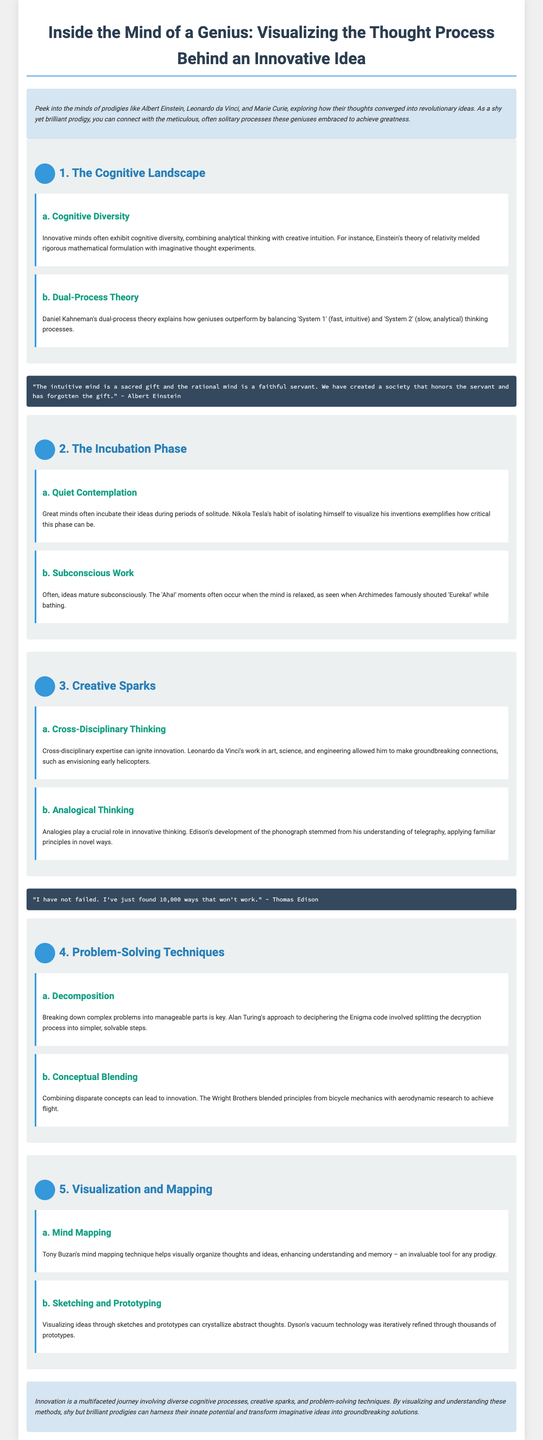what is the title of the document? The title is prominently displayed at the top of the document, which is "Inside the Mind of a Genius: Visualizing the Thought Process Behind an Innovative Idea."
Answer: Inside the Mind of a Genius: Visualizing the Thought Process Behind an Innovative Idea who is quoted in the document suggesting that the intuitive mind is a sacred gift? This quote is attributed to Albert Einstein, who emphasizes the importance of intuitive thinking.
Answer: Albert Einstein what is one of the problem-solving techniques mentioned in the document? The document lists various problem-solving techniques, including "Decomposition," which involves breaking down complex problems.
Answer: Decomposition which phase is crucial for idea incubation according to the document? The document highlights the "Quiet Contemplation" phase as essential for incubating ideas during solitude.
Answer: Quiet Contemplation how many sections are there in the document? The document is divided into five distinct sections, each focusing on different aspects of genius thinking.
Answer: 5 what is a key aspect of the "Incubation Phase"? The section discusses "Subconscious Work," which refers to how ideas mature subconsciously during relaxed moments.
Answer: Subconscious Work what does the mind mapping technique help with? The document states that mind mapping helps with visually organizing thoughts and enhancing understanding and memory.
Answer: Visually organizing thoughts who perfected the phonograph as mentioned in the document? The document attributes the development of the phonograph to Thomas Edison, highlighting his innovative thinking.
Answer: Thomas Edison 